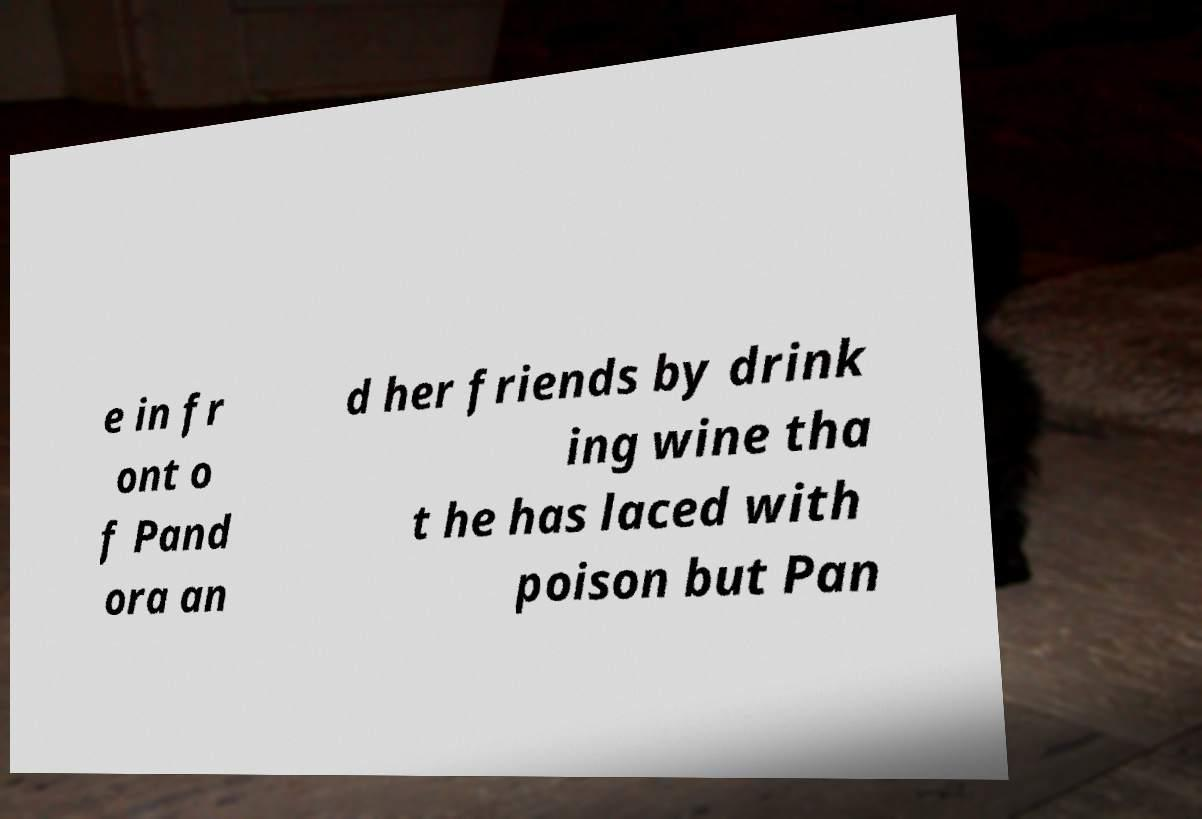Can you accurately transcribe the text from the provided image for me? e in fr ont o f Pand ora an d her friends by drink ing wine tha t he has laced with poison but Pan 